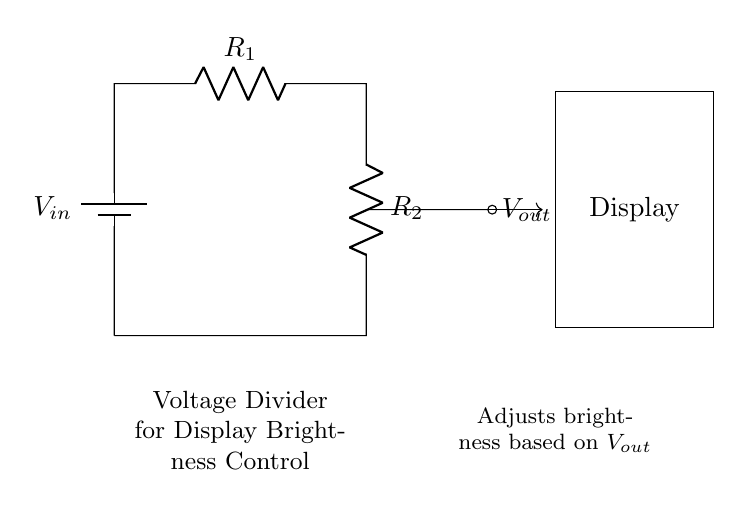What is the input voltage for this circuit? The circuit diagram shows a battery labeled as \( V_{in} \), indicating the input voltage.
Answer: \( V_{in} \) What are the two resistors in this circuit? The resistors connected in series are labeled \( R_1 \) and \( R_2 \) in the diagram, indicating the components used in the voltage divider.
Answer: \( R_1 \) and \( R_2 \) What is the purpose of \( V_{out} \) in this circuit? \( V_{out} \) is the output voltage taken from the junction of \( R_1 \) and \( R_2 \), which is used to adjust the brightness of the display based on the voltage division.
Answer: Adjust brightness How does the value of \( R_2 \) affect \( V_{out} \)? Increasing the value of \( R_2 \) would increase the output voltage \( V_{out} \) based on the voltage divider formula, which states that \( V_{out} \) is a fraction of \( V_{in} \) determined by the ratio of the resistors.
Answer: Increases \( V_{out} \) What is the relationship between \( V_{in} \), \( V_{out} \), \( R_1 \), and \( R_2 \)? The relationship is defined by the voltage divider rule: \( V_{out} = V_{in} \cdot \frac{R_2}{R_1 + R_2} \), which shows how the input voltage is divided between the resistors based on their values.
Answer: Voltage divider rule What does changing \( R_1 \) do to the output voltage? Changing \( R_1 \) alters the proportion of the resistive division; increasing \( R_1 \) lowers \( V_{out} \) whereas decreasing \( R_1 \) raises \( V_{out} \).
Answer: Affects \( V_{out} \) inversely What type of circuit is depicted in the diagram? The diagram illustrates a voltage divider circuit, which is specifically designed to reduce the voltage to a desired level by using two resistors.
Answer: Voltage divider circuit 